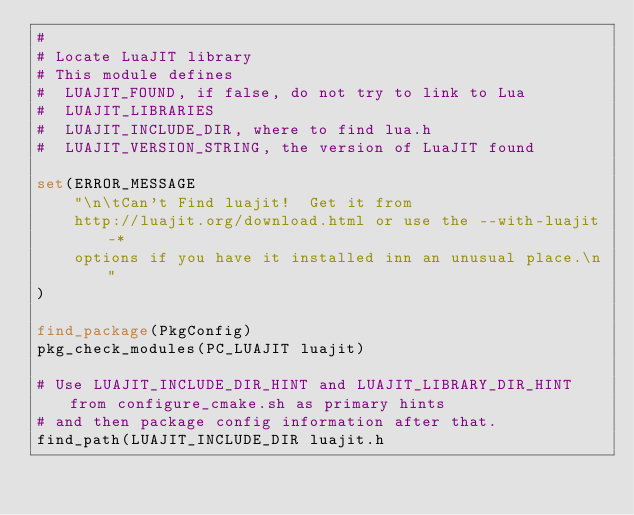Convert code to text. <code><loc_0><loc_0><loc_500><loc_500><_CMake_>#
# Locate LuaJIT library
# This module defines
#  LUAJIT_FOUND, if false, do not try to link to Lua
#  LUAJIT_LIBRARIES
#  LUAJIT_INCLUDE_DIR, where to find lua.h
#  LUAJIT_VERSION_STRING, the version of LuaJIT found

set(ERROR_MESSAGE
    "\n\tCan't Find luajit!  Get it from
    http://luajit.org/download.html or use the --with-luajit-*
    options if you have it installed inn an unusual place.\n"
)

find_package(PkgConfig)
pkg_check_modules(PC_LUAJIT luajit)

# Use LUAJIT_INCLUDE_DIR_HINT and LUAJIT_LIBRARY_DIR_HINT from configure_cmake.sh as primary hints
# and then package config information after that.
find_path(LUAJIT_INCLUDE_DIR luajit.h</code> 